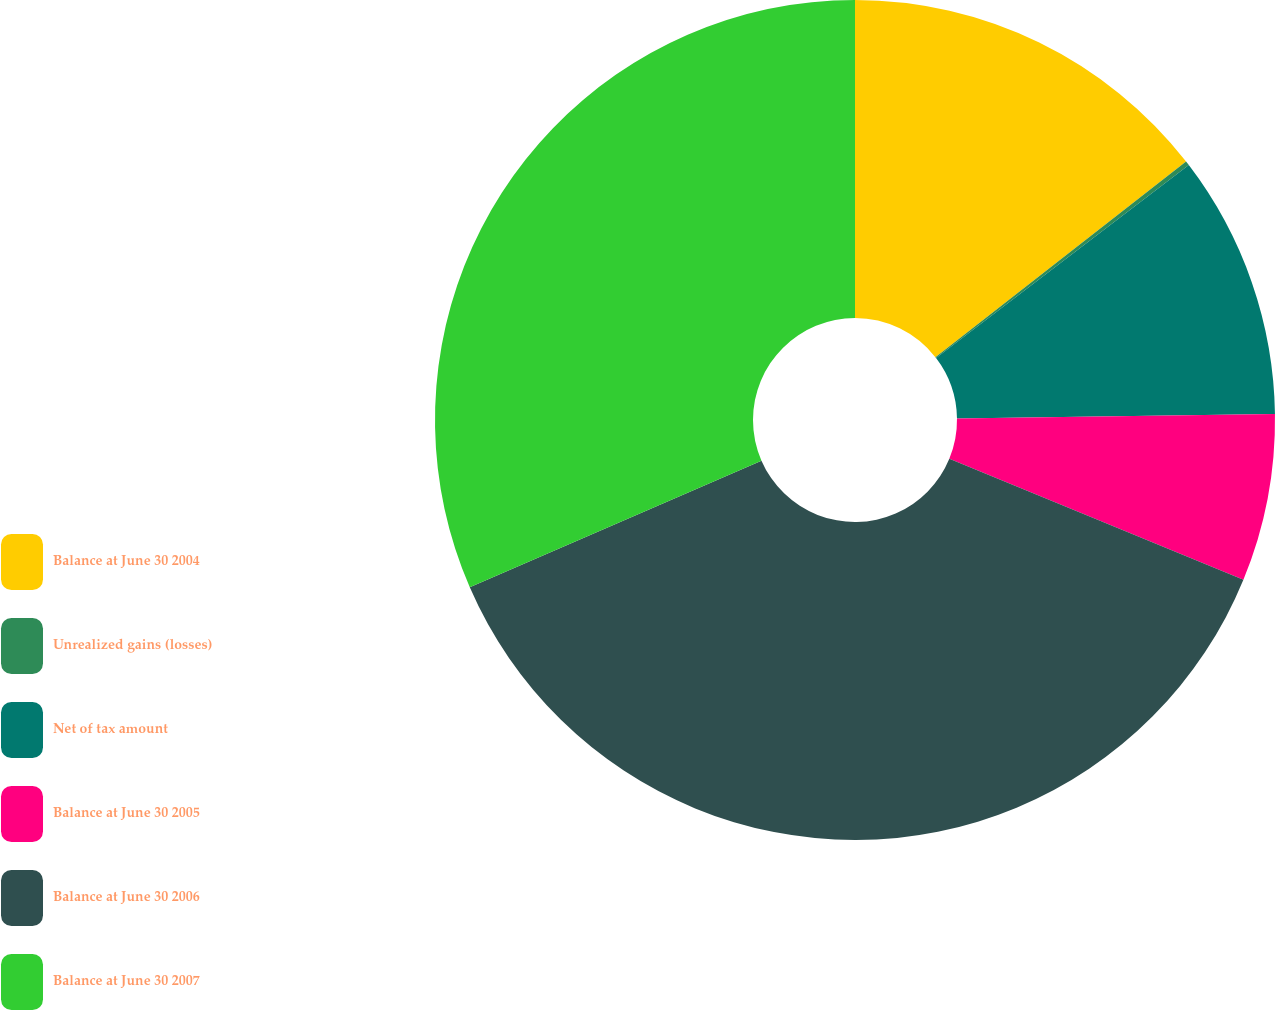Convert chart to OTSL. <chart><loc_0><loc_0><loc_500><loc_500><pie_chart><fcel>Balance at June 30 2004<fcel>Unrealized gains (losses)<fcel>Net of tax amount<fcel>Balance at June 30 2005<fcel>Balance at June 30 2006<fcel>Balance at June 30 2007<nl><fcel>14.45%<fcel>0.17%<fcel>10.15%<fcel>6.44%<fcel>37.26%<fcel>31.52%<nl></chart> 